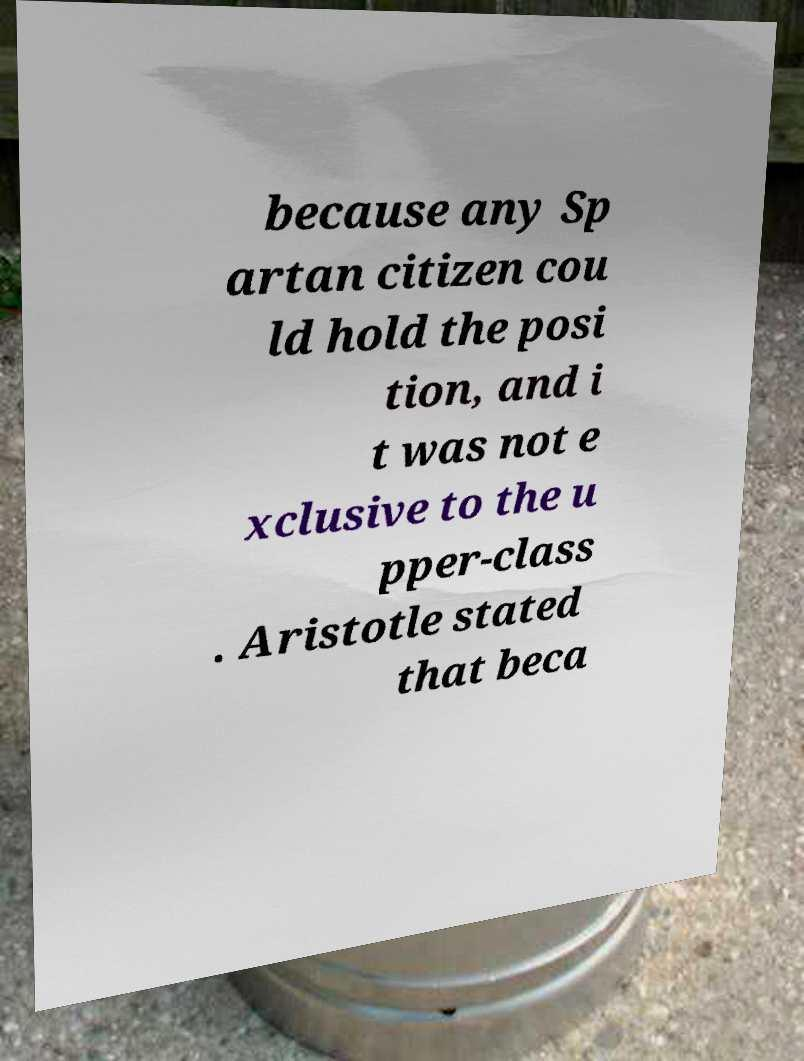Could you assist in decoding the text presented in this image and type it out clearly? because any Sp artan citizen cou ld hold the posi tion, and i t was not e xclusive to the u pper-class . Aristotle stated that beca 